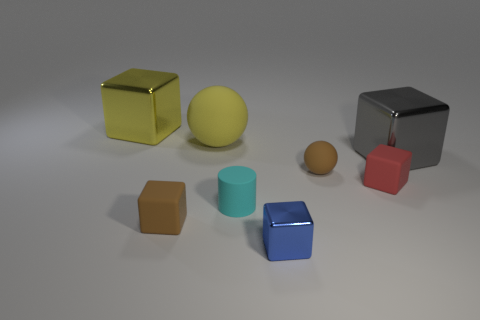Is the size of the yellow shiny block the same as the rubber sphere left of the small cyan cylinder?
Offer a terse response. Yes. There is another big metal thing that is the same shape as the big gray metal object; what is its color?
Offer a very short reply. Yellow. Do the sphere right of the big yellow sphere and the object that is to the right of the red object have the same size?
Ensure brevity in your answer.  No. Do the small cyan object and the small red object have the same shape?
Provide a short and direct response. No. How many objects are either large blocks right of the red cube or brown matte spheres?
Provide a succinct answer. 2. Are there any small blue things that have the same shape as the small red object?
Your response must be concise. Yes. Is the number of small brown balls left of the yellow cube the same as the number of blue metallic cubes?
Keep it short and to the point. No. What shape is the object that is the same color as the small sphere?
Keep it short and to the point. Cube. How many blue metal things are the same size as the cyan rubber cylinder?
Offer a terse response. 1. There is a yellow metal object; what number of yellow objects are right of it?
Make the answer very short. 1. 